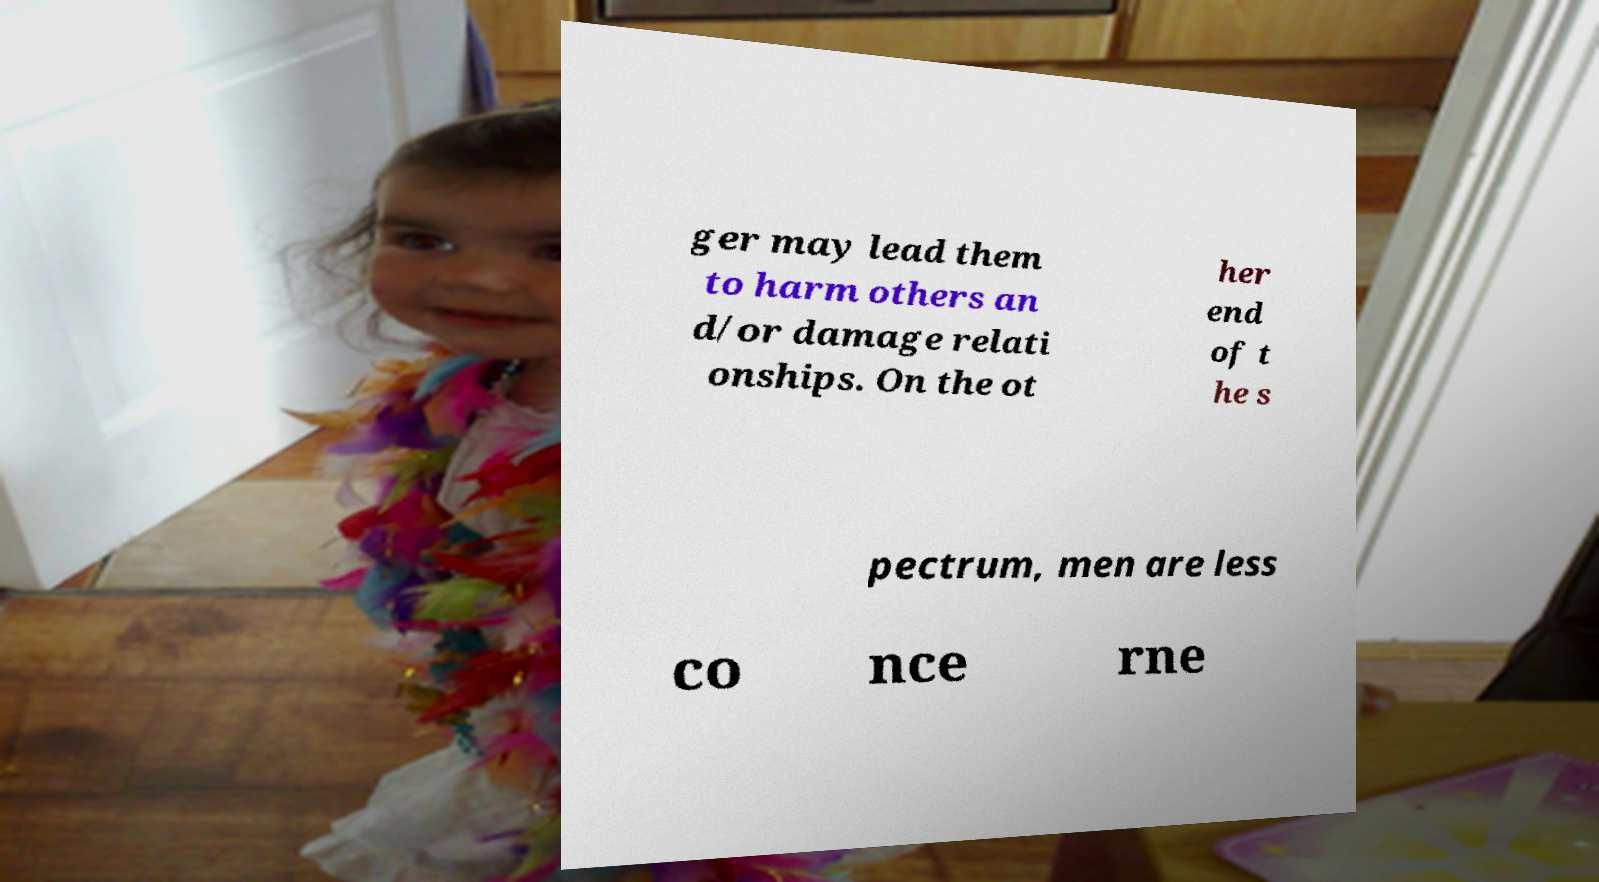Can you read and provide the text displayed in the image?This photo seems to have some interesting text. Can you extract and type it out for me? ger may lead them to harm others an d/or damage relati onships. On the ot her end of t he s pectrum, men are less co nce rne 